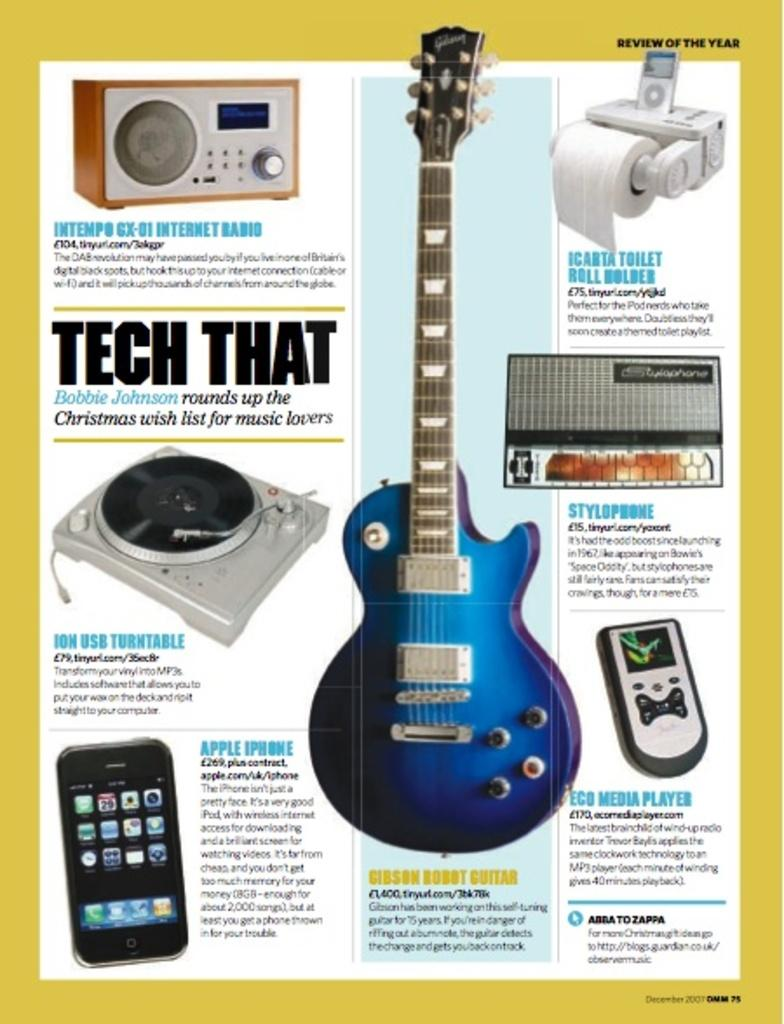<image>
Present a compact description of the photo's key features. A magazine spread about Tech That features phones and guitars. 